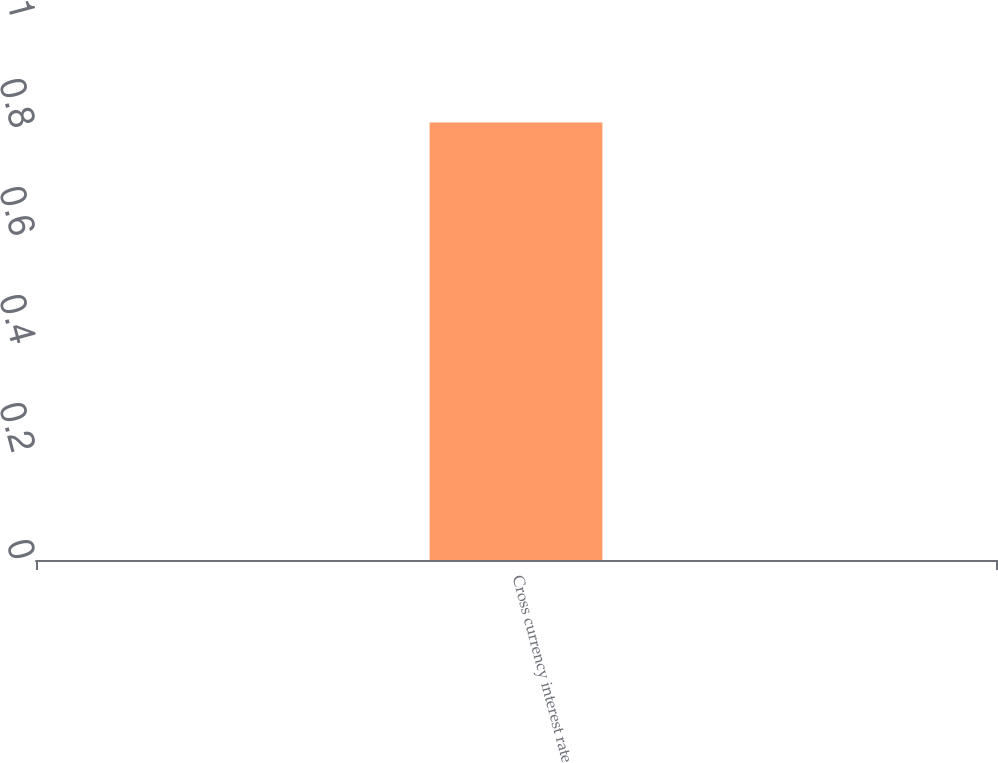<chart> <loc_0><loc_0><loc_500><loc_500><bar_chart><fcel>Cross currency interest rate<nl><fcel>0.81<nl></chart> 